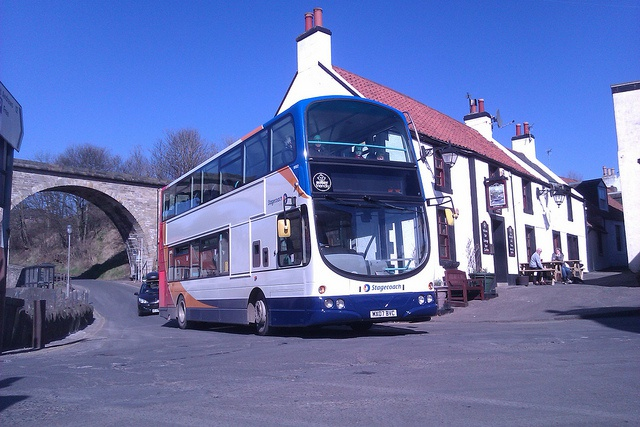Describe the objects in this image and their specific colors. I can see bus in blue, navy, lavender, and black tones, bench in blue, purple, and black tones, car in blue, navy, black, purple, and gray tones, bench in blue, darkgray, black, gray, and lavender tones, and people in blue, navy, and darkblue tones in this image. 